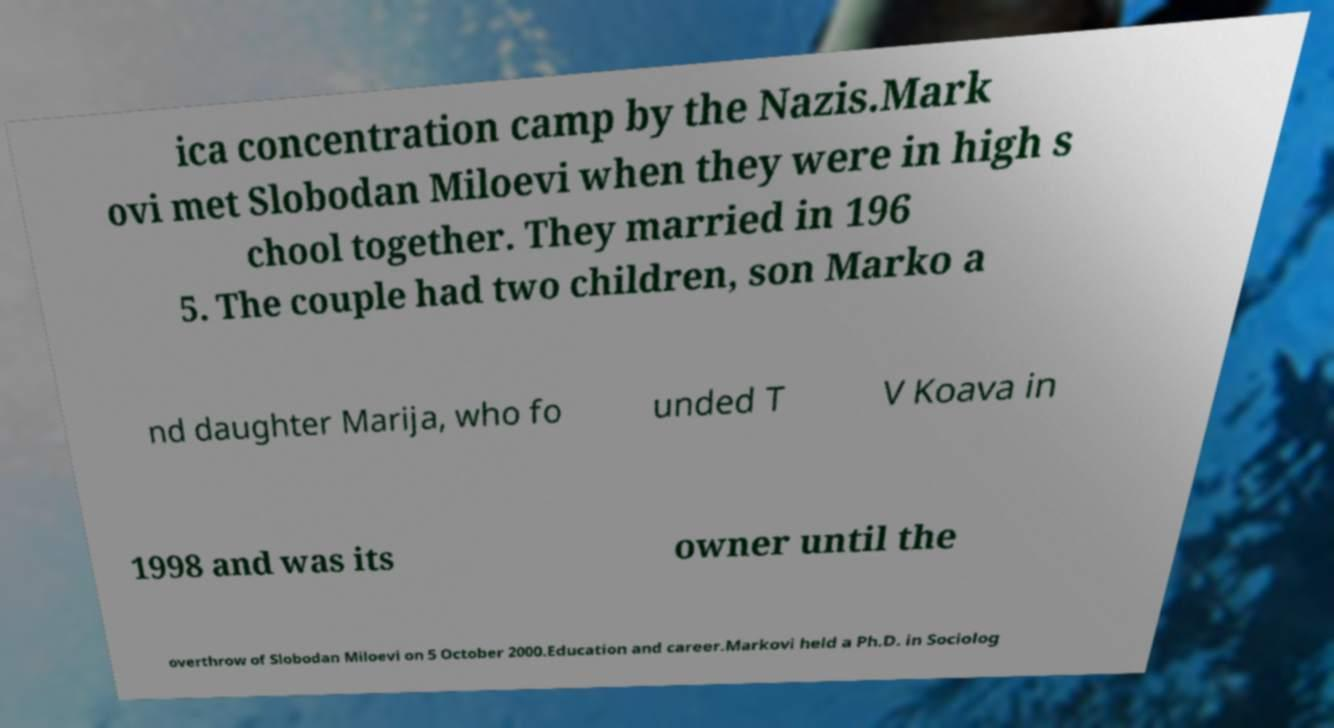Could you extract and type out the text from this image? ica concentration camp by the Nazis.Mark ovi met Slobodan Miloevi when they were in high s chool together. They married in 196 5. The couple had two children, son Marko a nd daughter Marija, who fo unded T V Koava in 1998 and was its owner until the overthrow of Slobodan Miloevi on 5 October 2000.Education and career.Markovi held a Ph.D. in Sociolog 